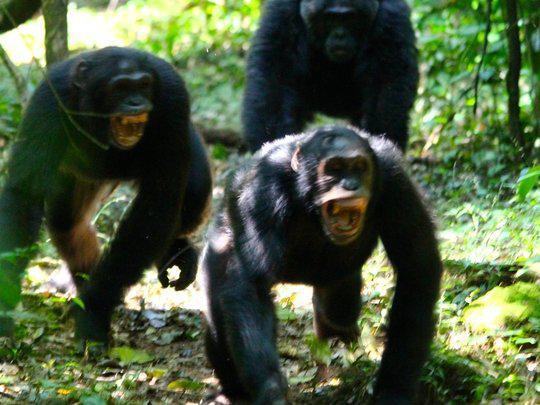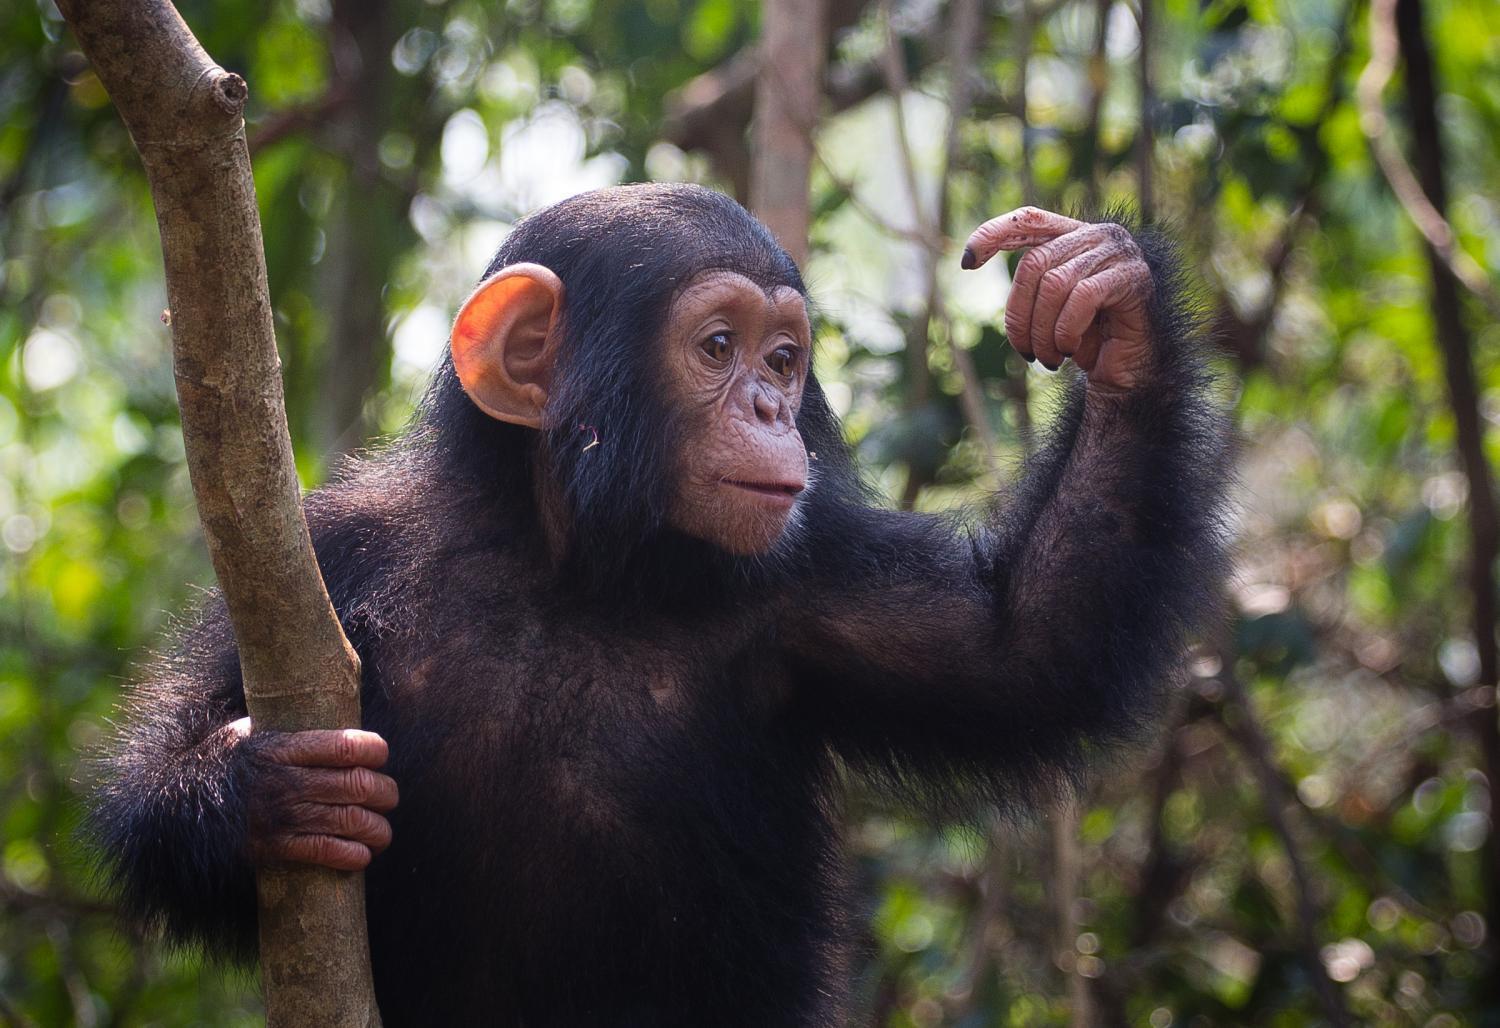The first image is the image on the left, the second image is the image on the right. Given the left and right images, does the statement "There is a baby monkey cuddling its mother in one of the images." hold true? Answer yes or no. No. 